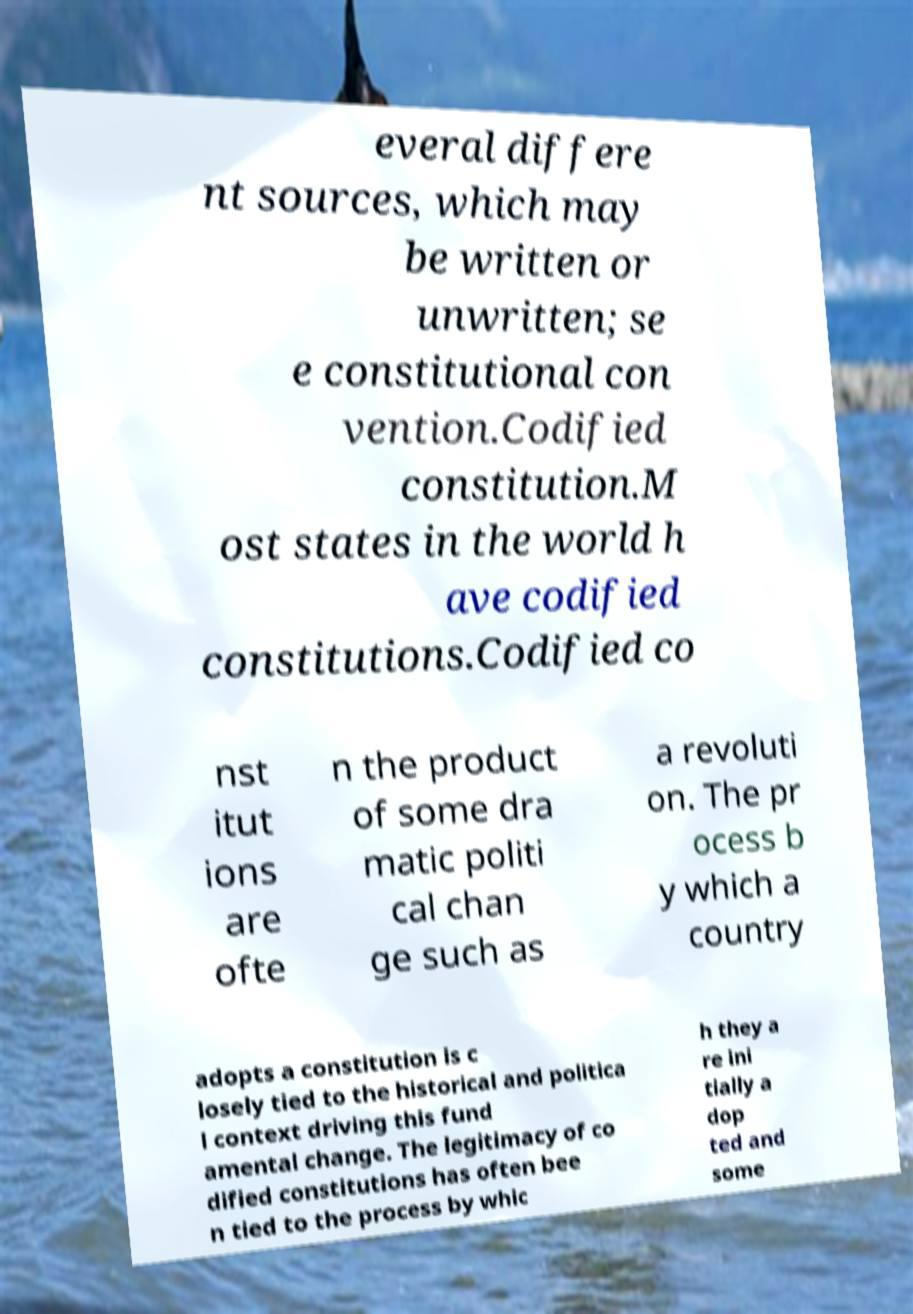Please identify and transcribe the text found in this image. everal differe nt sources, which may be written or unwritten; se e constitutional con vention.Codified constitution.M ost states in the world h ave codified constitutions.Codified co nst itut ions are ofte n the product of some dra matic politi cal chan ge such as a revoluti on. The pr ocess b y which a country adopts a constitution is c losely tied to the historical and politica l context driving this fund amental change. The legitimacy of co dified constitutions has often bee n tied to the process by whic h they a re ini tially a dop ted and some 